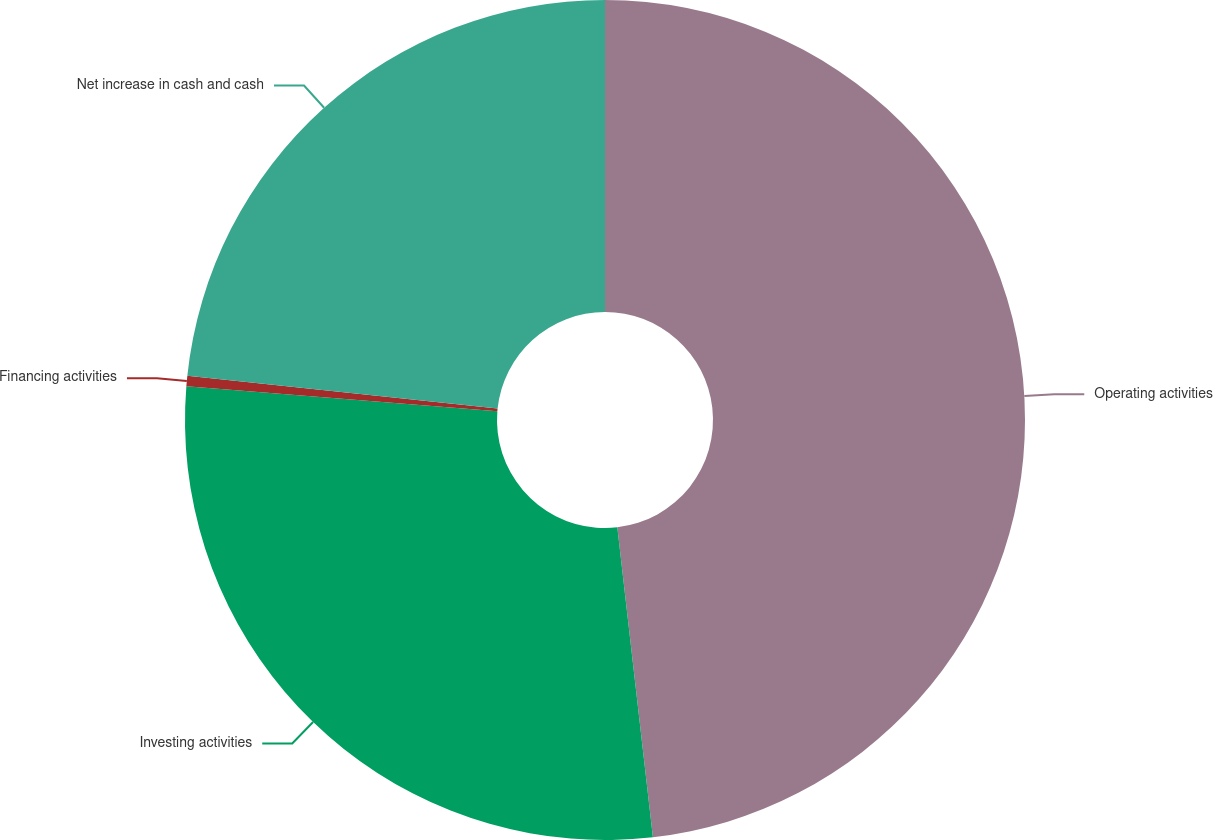Convert chart to OTSL. <chart><loc_0><loc_0><loc_500><loc_500><pie_chart><fcel>Operating activities<fcel>Investing activities<fcel>Financing activities<fcel>Net increase in cash and cash<nl><fcel>48.18%<fcel>28.1%<fcel>0.4%<fcel>23.32%<nl></chart> 